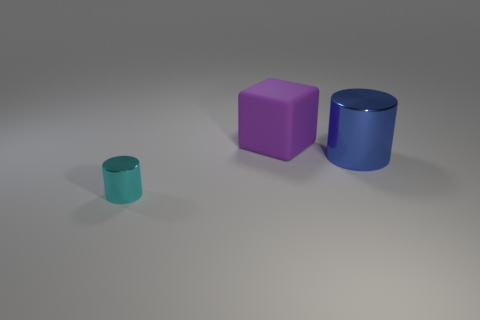Is the number of shiny cylinders in front of the large cylinder less than the number of tiny purple spheres?
Ensure brevity in your answer.  No. What color is the other big cylinder that is made of the same material as the cyan cylinder?
Provide a succinct answer. Blue. What is the size of the cylinder to the right of the rubber cube?
Ensure brevity in your answer.  Large. Does the tiny cyan object have the same material as the purple thing?
Keep it short and to the point. No. There is a metallic cylinder to the left of the metallic object behind the tiny cyan object; is there a small cyan thing that is behind it?
Your answer should be compact. No. What is the color of the matte cube?
Your answer should be very brief. Purple. There is a shiny object that is the same size as the purple rubber block; what color is it?
Make the answer very short. Blue. There is a thing that is in front of the large blue shiny thing; is its shape the same as the rubber object?
Make the answer very short. No. There is a metal thing that is in front of the metal thing on the right side of the purple matte object that is behind the big blue metal object; what color is it?
Give a very brief answer. Cyan. Are there any big metallic cylinders?
Provide a succinct answer. Yes. 